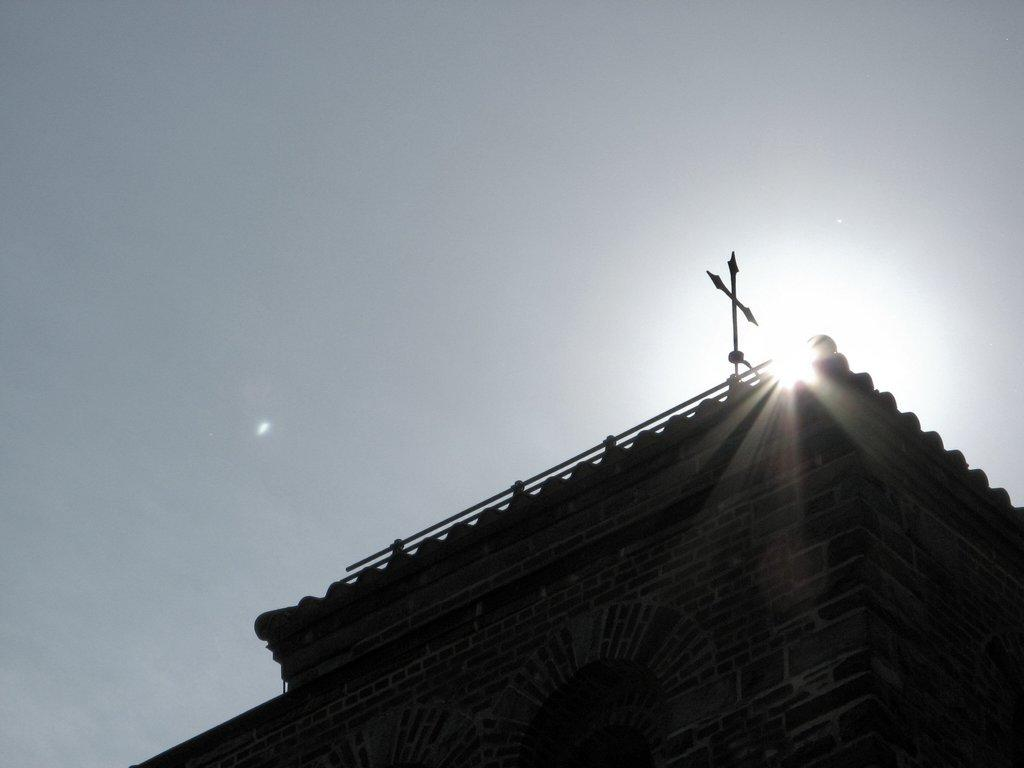What type of structure is present in the image? There is a building in the image. What symbol can be seen on the building? The building has a plus symbol on it. What celestial body is visible in the image? The sun is visible in the image. What else can be seen in the sky besides the sun? The sky is visible in the image. What color is the poison in the image? There is no poison present in the image. What type of science is being conducted in the image? There is no indication of any scientific activity in the image. 